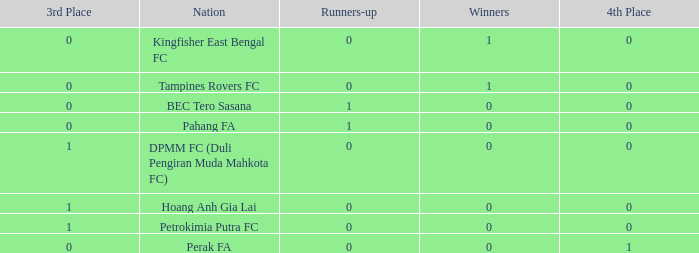Name the average 3rd place with winners of 0, 4th place of 0 and nation of pahang fa 0.0. 